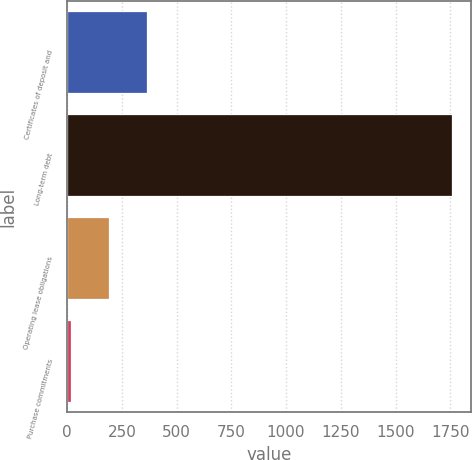Convert chart to OTSL. <chart><loc_0><loc_0><loc_500><loc_500><bar_chart><fcel>Certificates of deposit and<fcel>Long-term debt<fcel>Operating lease obligations<fcel>Purchase commitments<nl><fcel>364.4<fcel>1758<fcel>190.2<fcel>16<nl></chart> 